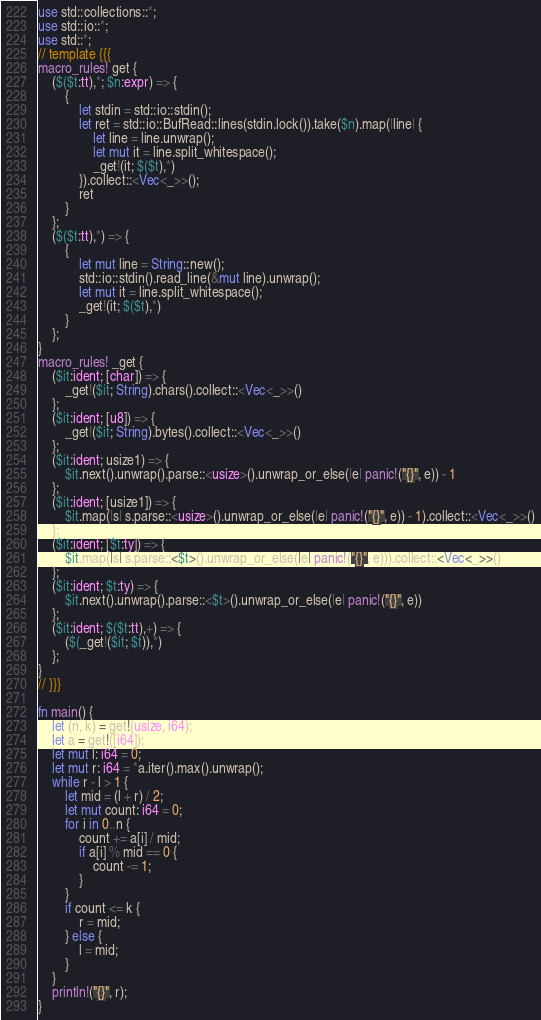Convert code to text. <code><loc_0><loc_0><loc_500><loc_500><_Rust_>use std::collections::*;
use std::io::*;
use std::*;
// template {{{
macro_rules! get {
    ($($t:tt),*; $n:expr) => {
        {
            let stdin = std::io::stdin();
            let ret = std::io::BufRead::lines(stdin.lock()).take($n).map(|line| {
                let line = line.unwrap();
                let mut it = line.split_whitespace();
                _get!(it; $($t),*)
            }).collect::<Vec<_>>();
            ret
        }
    };
    ($($t:tt),*) => {
        {
            let mut line = String::new();
            std::io::stdin().read_line(&mut line).unwrap();
            let mut it = line.split_whitespace();
            _get!(it; $($t),*)
        }
    };
}
macro_rules! _get {
    ($it:ident; [char]) => {
        _get!($it; String).chars().collect::<Vec<_>>()
    };
    ($it:ident; [u8]) => {
        _get!($it; String).bytes().collect::<Vec<_>>()
    };
    ($it:ident; usize1) => {
        $it.next().unwrap().parse::<usize>().unwrap_or_else(|e| panic!("{}", e)) - 1
    };
    ($it:ident; [usize1]) => {
        $it.map(|s| s.parse::<usize>().unwrap_or_else(|e| panic!("{}", e)) - 1).collect::<Vec<_>>()
    };
    ($it:ident; [$t:ty]) => {
        $it.map(|s| s.parse::<$t>().unwrap_or_else(|e| panic!("{}", e))).collect::<Vec<_>>()
    };
    ($it:ident; $t:ty) => {
        $it.next().unwrap().parse::<$t>().unwrap_or_else(|e| panic!("{}", e))
    };
    ($it:ident; $($t:tt),+) => {
        ($(_get!($it; $t)),*)
    };
}
// }}}

fn main() {
    let (n, k) = get!(usize, i64);
    let a = get!([i64]);
    let mut l: i64 = 0;
    let mut r: i64 = *a.iter().max().unwrap();
    while r - l > 1 {
        let mid = (l + r) / 2;
        let mut count: i64 = 0;
        for i in 0..n {
            count += a[i] / mid;
            if a[i] % mid == 0 {
                count -= 1;
            }
        }
        if count <= k {
            r = mid;
        } else {
            l = mid;
        }
    }
    println!("{}", r);
}
</code> 